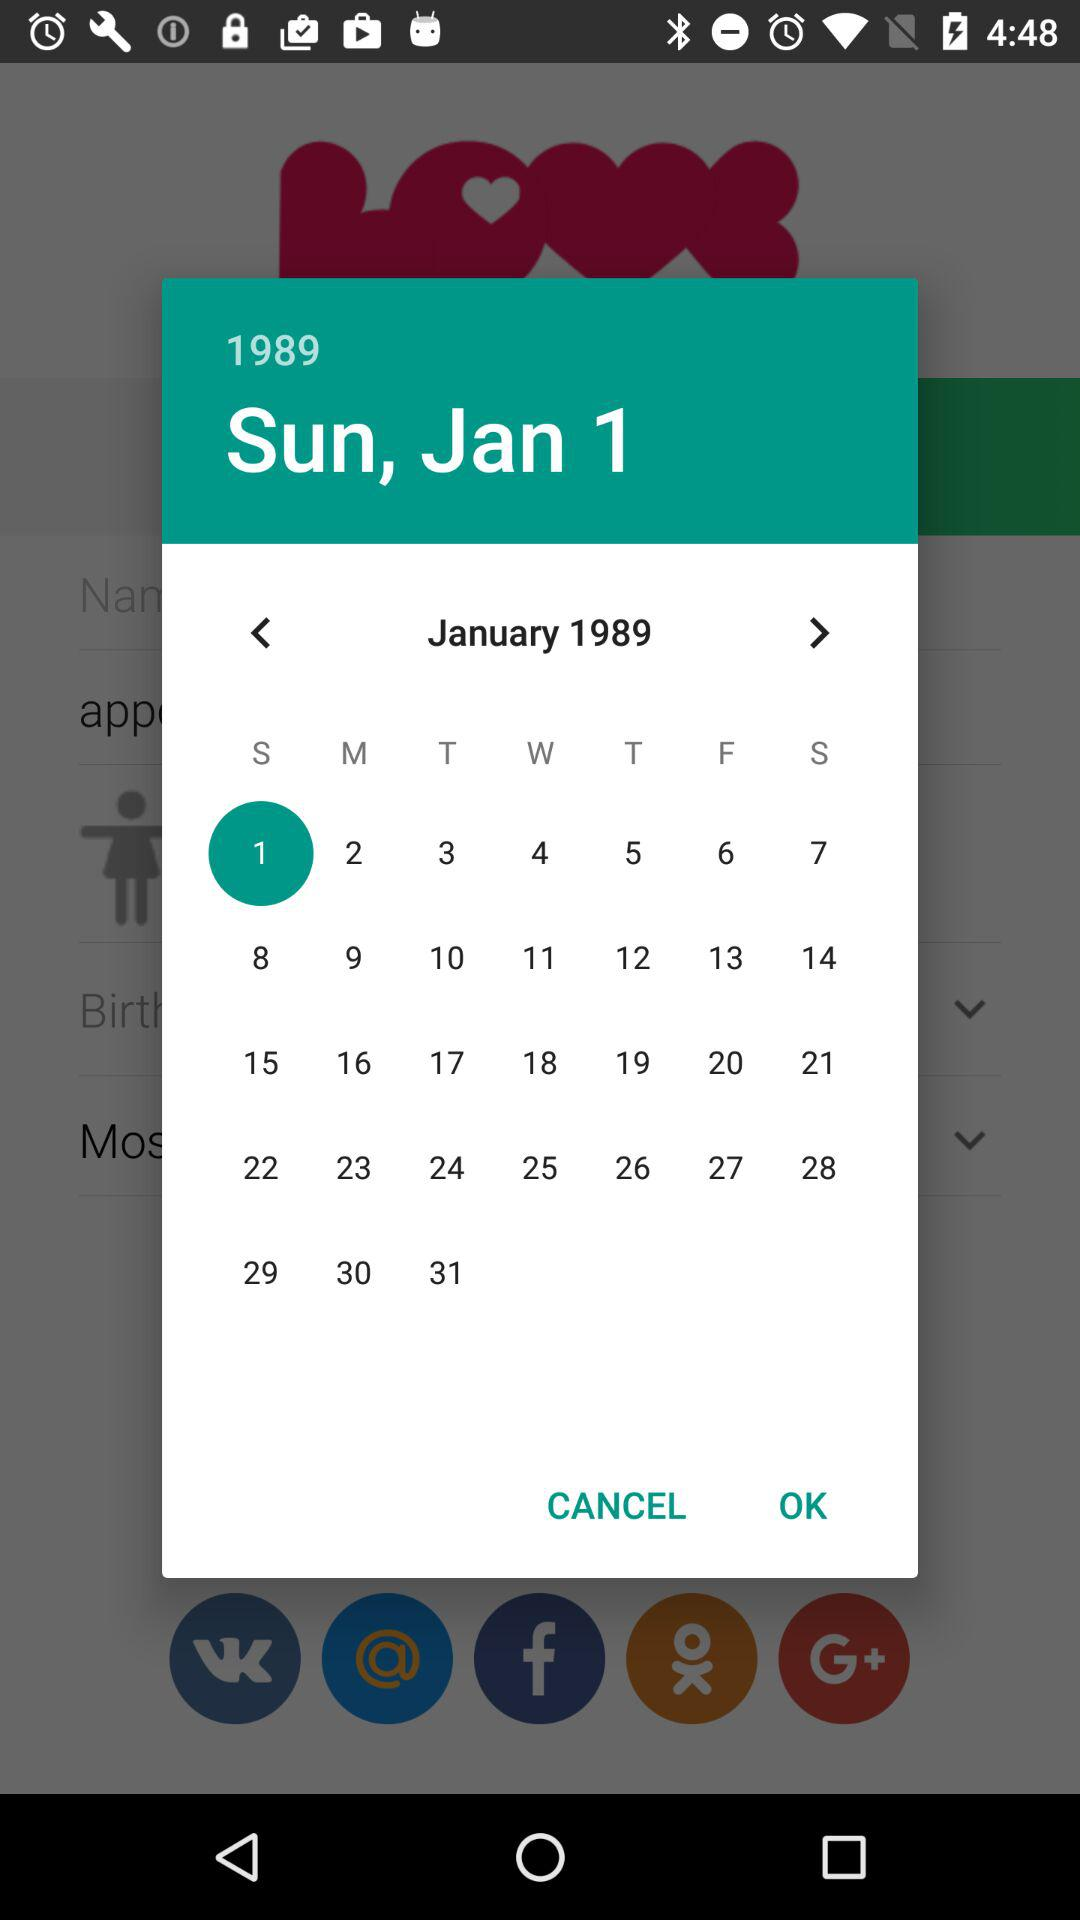Which gender did the user select?
When the provided information is insufficient, respond with <no answer>. <no answer> 